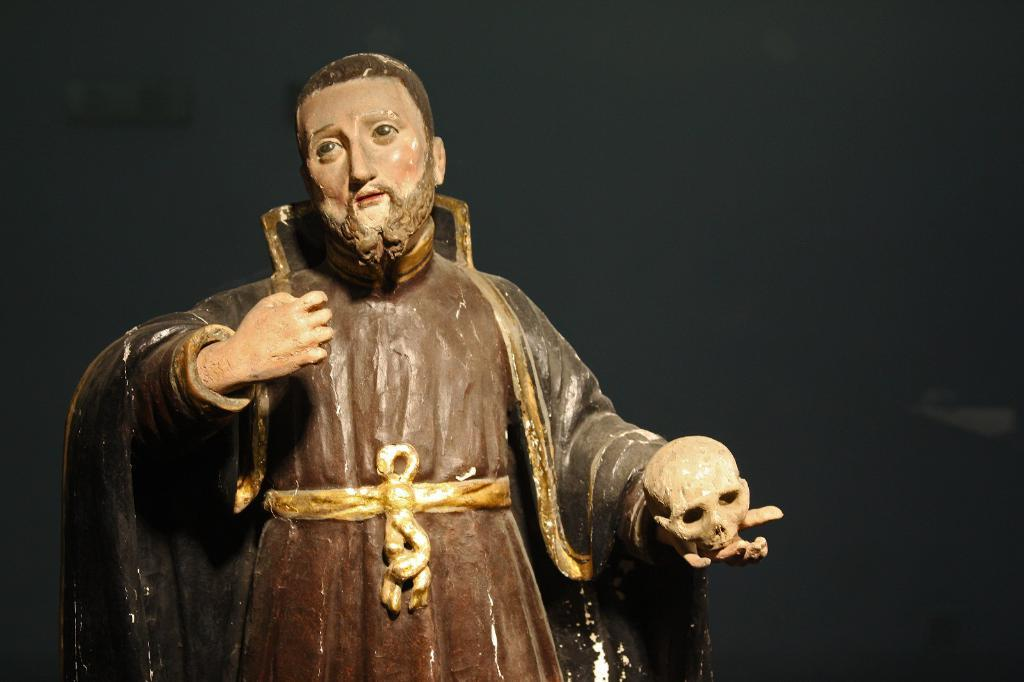What is the main subject of the image? The main subject of the image is a human sculpture. What type of metal is used to create the pizzas in the image? There are no pizzas present in the image, and therefore no metal can be associated with them. 